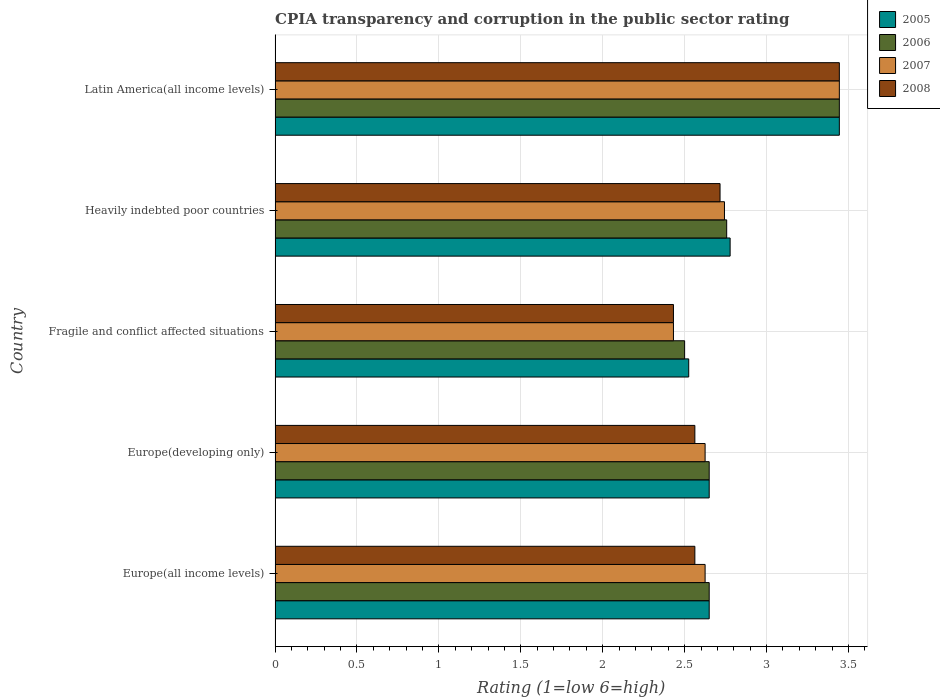How many groups of bars are there?
Provide a short and direct response. 5. Are the number of bars on each tick of the Y-axis equal?
Your answer should be compact. Yes. How many bars are there on the 1st tick from the top?
Make the answer very short. 4. What is the label of the 1st group of bars from the top?
Your answer should be compact. Latin America(all income levels). In how many cases, is the number of bars for a given country not equal to the number of legend labels?
Make the answer very short. 0. Across all countries, what is the maximum CPIA rating in 2006?
Offer a very short reply. 3.44. Across all countries, what is the minimum CPIA rating in 2005?
Provide a succinct answer. 2.52. In which country was the CPIA rating in 2005 maximum?
Keep it short and to the point. Latin America(all income levels). In which country was the CPIA rating in 2008 minimum?
Make the answer very short. Fragile and conflict affected situations. What is the total CPIA rating in 2007 in the graph?
Provide a short and direct response. 13.87. What is the difference between the CPIA rating in 2005 in Europe(developing only) and that in Heavily indebted poor countries?
Provide a succinct answer. -0.13. What is the difference between the CPIA rating in 2006 in Latin America(all income levels) and the CPIA rating in 2005 in Europe(developing only)?
Provide a short and direct response. 0.79. What is the average CPIA rating in 2005 per country?
Make the answer very short. 2.81. What is the difference between the CPIA rating in 2005 and CPIA rating in 2008 in Europe(developing only)?
Your answer should be very brief. 0.09. What is the ratio of the CPIA rating in 2008 in Fragile and conflict affected situations to that in Latin America(all income levels)?
Provide a short and direct response. 0.71. What is the difference between the highest and the second highest CPIA rating in 2006?
Your response must be concise. 0.69. What is the difference between the highest and the lowest CPIA rating in 2005?
Offer a terse response. 0.92. In how many countries, is the CPIA rating in 2006 greater than the average CPIA rating in 2006 taken over all countries?
Offer a very short reply. 1. Is the sum of the CPIA rating in 2006 in Europe(all income levels) and Latin America(all income levels) greater than the maximum CPIA rating in 2005 across all countries?
Provide a succinct answer. Yes. What does the 1st bar from the top in Fragile and conflict affected situations represents?
Give a very brief answer. 2008. What does the 4th bar from the bottom in Europe(all income levels) represents?
Offer a terse response. 2008. How many bars are there?
Keep it short and to the point. 20. What is the difference between two consecutive major ticks on the X-axis?
Offer a very short reply. 0.5. Are the values on the major ticks of X-axis written in scientific E-notation?
Ensure brevity in your answer.  No. Does the graph contain any zero values?
Your response must be concise. No. Does the graph contain grids?
Make the answer very short. Yes. Where does the legend appear in the graph?
Make the answer very short. Top right. How many legend labels are there?
Keep it short and to the point. 4. How are the legend labels stacked?
Offer a very short reply. Vertical. What is the title of the graph?
Your answer should be compact. CPIA transparency and corruption in the public sector rating. What is the Rating (1=low 6=high) in 2005 in Europe(all income levels)?
Your response must be concise. 2.65. What is the Rating (1=low 6=high) of 2006 in Europe(all income levels)?
Make the answer very short. 2.65. What is the Rating (1=low 6=high) in 2007 in Europe(all income levels)?
Provide a short and direct response. 2.62. What is the Rating (1=low 6=high) of 2008 in Europe(all income levels)?
Offer a terse response. 2.56. What is the Rating (1=low 6=high) in 2005 in Europe(developing only)?
Your response must be concise. 2.65. What is the Rating (1=low 6=high) of 2006 in Europe(developing only)?
Keep it short and to the point. 2.65. What is the Rating (1=low 6=high) of 2007 in Europe(developing only)?
Keep it short and to the point. 2.62. What is the Rating (1=low 6=high) of 2008 in Europe(developing only)?
Ensure brevity in your answer.  2.56. What is the Rating (1=low 6=high) in 2005 in Fragile and conflict affected situations?
Offer a very short reply. 2.52. What is the Rating (1=low 6=high) of 2006 in Fragile and conflict affected situations?
Ensure brevity in your answer.  2.5. What is the Rating (1=low 6=high) of 2007 in Fragile and conflict affected situations?
Ensure brevity in your answer.  2.43. What is the Rating (1=low 6=high) of 2008 in Fragile and conflict affected situations?
Your answer should be very brief. 2.43. What is the Rating (1=low 6=high) of 2005 in Heavily indebted poor countries?
Keep it short and to the point. 2.78. What is the Rating (1=low 6=high) in 2006 in Heavily indebted poor countries?
Offer a terse response. 2.76. What is the Rating (1=low 6=high) of 2007 in Heavily indebted poor countries?
Keep it short and to the point. 2.74. What is the Rating (1=low 6=high) of 2008 in Heavily indebted poor countries?
Make the answer very short. 2.72. What is the Rating (1=low 6=high) of 2005 in Latin America(all income levels)?
Give a very brief answer. 3.44. What is the Rating (1=low 6=high) in 2006 in Latin America(all income levels)?
Make the answer very short. 3.44. What is the Rating (1=low 6=high) of 2007 in Latin America(all income levels)?
Offer a very short reply. 3.44. What is the Rating (1=low 6=high) in 2008 in Latin America(all income levels)?
Ensure brevity in your answer.  3.44. Across all countries, what is the maximum Rating (1=low 6=high) of 2005?
Offer a terse response. 3.44. Across all countries, what is the maximum Rating (1=low 6=high) in 2006?
Make the answer very short. 3.44. Across all countries, what is the maximum Rating (1=low 6=high) of 2007?
Keep it short and to the point. 3.44. Across all countries, what is the maximum Rating (1=low 6=high) in 2008?
Your answer should be compact. 3.44. Across all countries, what is the minimum Rating (1=low 6=high) in 2005?
Provide a succinct answer. 2.52. Across all countries, what is the minimum Rating (1=low 6=high) of 2007?
Offer a terse response. 2.43. Across all countries, what is the minimum Rating (1=low 6=high) of 2008?
Ensure brevity in your answer.  2.43. What is the total Rating (1=low 6=high) in 2005 in the graph?
Ensure brevity in your answer.  14.05. What is the total Rating (1=low 6=high) of 2006 in the graph?
Your response must be concise. 14. What is the total Rating (1=low 6=high) in 2007 in the graph?
Ensure brevity in your answer.  13.87. What is the total Rating (1=low 6=high) of 2008 in the graph?
Provide a short and direct response. 13.72. What is the difference between the Rating (1=low 6=high) in 2005 in Europe(all income levels) and that in Europe(developing only)?
Make the answer very short. 0. What is the difference between the Rating (1=low 6=high) in 2006 in Europe(all income levels) and that in Europe(developing only)?
Offer a very short reply. 0. What is the difference between the Rating (1=low 6=high) in 2007 in Europe(all income levels) and that in Europe(developing only)?
Offer a very short reply. 0. What is the difference between the Rating (1=low 6=high) in 2008 in Europe(all income levels) and that in Europe(developing only)?
Your answer should be compact. 0. What is the difference between the Rating (1=low 6=high) in 2006 in Europe(all income levels) and that in Fragile and conflict affected situations?
Ensure brevity in your answer.  0.15. What is the difference between the Rating (1=low 6=high) in 2007 in Europe(all income levels) and that in Fragile and conflict affected situations?
Offer a very short reply. 0.19. What is the difference between the Rating (1=low 6=high) in 2008 in Europe(all income levels) and that in Fragile and conflict affected situations?
Give a very brief answer. 0.13. What is the difference between the Rating (1=low 6=high) of 2005 in Europe(all income levels) and that in Heavily indebted poor countries?
Your response must be concise. -0.13. What is the difference between the Rating (1=low 6=high) of 2006 in Europe(all income levels) and that in Heavily indebted poor countries?
Keep it short and to the point. -0.11. What is the difference between the Rating (1=low 6=high) in 2007 in Europe(all income levels) and that in Heavily indebted poor countries?
Offer a terse response. -0.12. What is the difference between the Rating (1=low 6=high) of 2008 in Europe(all income levels) and that in Heavily indebted poor countries?
Give a very brief answer. -0.15. What is the difference between the Rating (1=low 6=high) in 2005 in Europe(all income levels) and that in Latin America(all income levels)?
Give a very brief answer. -0.79. What is the difference between the Rating (1=low 6=high) in 2006 in Europe(all income levels) and that in Latin America(all income levels)?
Your answer should be very brief. -0.79. What is the difference between the Rating (1=low 6=high) in 2007 in Europe(all income levels) and that in Latin America(all income levels)?
Offer a terse response. -0.82. What is the difference between the Rating (1=low 6=high) of 2008 in Europe(all income levels) and that in Latin America(all income levels)?
Offer a very short reply. -0.88. What is the difference between the Rating (1=low 6=high) in 2005 in Europe(developing only) and that in Fragile and conflict affected situations?
Keep it short and to the point. 0.12. What is the difference between the Rating (1=low 6=high) in 2007 in Europe(developing only) and that in Fragile and conflict affected situations?
Offer a terse response. 0.19. What is the difference between the Rating (1=low 6=high) of 2008 in Europe(developing only) and that in Fragile and conflict affected situations?
Keep it short and to the point. 0.13. What is the difference between the Rating (1=low 6=high) of 2005 in Europe(developing only) and that in Heavily indebted poor countries?
Give a very brief answer. -0.13. What is the difference between the Rating (1=low 6=high) of 2006 in Europe(developing only) and that in Heavily indebted poor countries?
Your answer should be very brief. -0.11. What is the difference between the Rating (1=low 6=high) in 2007 in Europe(developing only) and that in Heavily indebted poor countries?
Ensure brevity in your answer.  -0.12. What is the difference between the Rating (1=low 6=high) of 2008 in Europe(developing only) and that in Heavily indebted poor countries?
Your answer should be compact. -0.15. What is the difference between the Rating (1=low 6=high) in 2005 in Europe(developing only) and that in Latin America(all income levels)?
Ensure brevity in your answer.  -0.79. What is the difference between the Rating (1=low 6=high) in 2006 in Europe(developing only) and that in Latin America(all income levels)?
Provide a succinct answer. -0.79. What is the difference between the Rating (1=low 6=high) of 2007 in Europe(developing only) and that in Latin America(all income levels)?
Your response must be concise. -0.82. What is the difference between the Rating (1=low 6=high) of 2008 in Europe(developing only) and that in Latin America(all income levels)?
Your response must be concise. -0.88. What is the difference between the Rating (1=low 6=high) of 2005 in Fragile and conflict affected situations and that in Heavily indebted poor countries?
Offer a very short reply. -0.25. What is the difference between the Rating (1=low 6=high) of 2006 in Fragile and conflict affected situations and that in Heavily indebted poor countries?
Ensure brevity in your answer.  -0.26. What is the difference between the Rating (1=low 6=high) in 2007 in Fragile and conflict affected situations and that in Heavily indebted poor countries?
Provide a short and direct response. -0.31. What is the difference between the Rating (1=low 6=high) in 2008 in Fragile and conflict affected situations and that in Heavily indebted poor countries?
Provide a succinct answer. -0.28. What is the difference between the Rating (1=low 6=high) in 2005 in Fragile and conflict affected situations and that in Latin America(all income levels)?
Your answer should be compact. -0.92. What is the difference between the Rating (1=low 6=high) of 2006 in Fragile and conflict affected situations and that in Latin America(all income levels)?
Your response must be concise. -0.94. What is the difference between the Rating (1=low 6=high) in 2007 in Fragile and conflict affected situations and that in Latin America(all income levels)?
Offer a terse response. -1.01. What is the difference between the Rating (1=low 6=high) in 2008 in Fragile and conflict affected situations and that in Latin America(all income levels)?
Offer a terse response. -1.01. What is the difference between the Rating (1=low 6=high) of 2006 in Heavily indebted poor countries and that in Latin America(all income levels)?
Offer a very short reply. -0.69. What is the difference between the Rating (1=low 6=high) in 2007 in Heavily indebted poor countries and that in Latin America(all income levels)?
Your answer should be compact. -0.7. What is the difference between the Rating (1=low 6=high) in 2008 in Heavily indebted poor countries and that in Latin America(all income levels)?
Your response must be concise. -0.73. What is the difference between the Rating (1=low 6=high) of 2005 in Europe(all income levels) and the Rating (1=low 6=high) of 2007 in Europe(developing only)?
Keep it short and to the point. 0.03. What is the difference between the Rating (1=low 6=high) of 2005 in Europe(all income levels) and the Rating (1=low 6=high) of 2008 in Europe(developing only)?
Your response must be concise. 0.09. What is the difference between the Rating (1=low 6=high) in 2006 in Europe(all income levels) and the Rating (1=low 6=high) in 2007 in Europe(developing only)?
Make the answer very short. 0.03. What is the difference between the Rating (1=low 6=high) in 2006 in Europe(all income levels) and the Rating (1=low 6=high) in 2008 in Europe(developing only)?
Your response must be concise. 0.09. What is the difference between the Rating (1=low 6=high) of 2007 in Europe(all income levels) and the Rating (1=low 6=high) of 2008 in Europe(developing only)?
Offer a terse response. 0.06. What is the difference between the Rating (1=low 6=high) in 2005 in Europe(all income levels) and the Rating (1=low 6=high) in 2007 in Fragile and conflict affected situations?
Keep it short and to the point. 0.22. What is the difference between the Rating (1=low 6=high) of 2005 in Europe(all income levels) and the Rating (1=low 6=high) of 2008 in Fragile and conflict affected situations?
Your answer should be very brief. 0.22. What is the difference between the Rating (1=low 6=high) of 2006 in Europe(all income levels) and the Rating (1=low 6=high) of 2007 in Fragile and conflict affected situations?
Keep it short and to the point. 0.22. What is the difference between the Rating (1=low 6=high) of 2006 in Europe(all income levels) and the Rating (1=low 6=high) of 2008 in Fragile and conflict affected situations?
Offer a terse response. 0.22. What is the difference between the Rating (1=low 6=high) in 2007 in Europe(all income levels) and the Rating (1=low 6=high) in 2008 in Fragile and conflict affected situations?
Make the answer very short. 0.19. What is the difference between the Rating (1=low 6=high) in 2005 in Europe(all income levels) and the Rating (1=low 6=high) in 2006 in Heavily indebted poor countries?
Keep it short and to the point. -0.11. What is the difference between the Rating (1=low 6=high) of 2005 in Europe(all income levels) and the Rating (1=low 6=high) of 2007 in Heavily indebted poor countries?
Your answer should be compact. -0.09. What is the difference between the Rating (1=low 6=high) of 2005 in Europe(all income levels) and the Rating (1=low 6=high) of 2008 in Heavily indebted poor countries?
Your response must be concise. -0.07. What is the difference between the Rating (1=low 6=high) of 2006 in Europe(all income levels) and the Rating (1=low 6=high) of 2007 in Heavily indebted poor countries?
Keep it short and to the point. -0.09. What is the difference between the Rating (1=low 6=high) of 2006 in Europe(all income levels) and the Rating (1=low 6=high) of 2008 in Heavily indebted poor countries?
Your response must be concise. -0.07. What is the difference between the Rating (1=low 6=high) of 2007 in Europe(all income levels) and the Rating (1=low 6=high) of 2008 in Heavily indebted poor countries?
Your answer should be very brief. -0.09. What is the difference between the Rating (1=low 6=high) in 2005 in Europe(all income levels) and the Rating (1=low 6=high) in 2006 in Latin America(all income levels)?
Keep it short and to the point. -0.79. What is the difference between the Rating (1=low 6=high) of 2005 in Europe(all income levels) and the Rating (1=low 6=high) of 2007 in Latin America(all income levels)?
Your answer should be very brief. -0.79. What is the difference between the Rating (1=low 6=high) in 2005 in Europe(all income levels) and the Rating (1=low 6=high) in 2008 in Latin America(all income levels)?
Offer a terse response. -0.79. What is the difference between the Rating (1=low 6=high) of 2006 in Europe(all income levels) and the Rating (1=low 6=high) of 2007 in Latin America(all income levels)?
Make the answer very short. -0.79. What is the difference between the Rating (1=low 6=high) of 2006 in Europe(all income levels) and the Rating (1=low 6=high) of 2008 in Latin America(all income levels)?
Your answer should be very brief. -0.79. What is the difference between the Rating (1=low 6=high) of 2007 in Europe(all income levels) and the Rating (1=low 6=high) of 2008 in Latin America(all income levels)?
Give a very brief answer. -0.82. What is the difference between the Rating (1=low 6=high) of 2005 in Europe(developing only) and the Rating (1=low 6=high) of 2007 in Fragile and conflict affected situations?
Give a very brief answer. 0.22. What is the difference between the Rating (1=low 6=high) in 2005 in Europe(developing only) and the Rating (1=low 6=high) in 2008 in Fragile and conflict affected situations?
Provide a short and direct response. 0.22. What is the difference between the Rating (1=low 6=high) in 2006 in Europe(developing only) and the Rating (1=low 6=high) in 2007 in Fragile and conflict affected situations?
Make the answer very short. 0.22. What is the difference between the Rating (1=low 6=high) in 2006 in Europe(developing only) and the Rating (1=low 6=high) in 2008 in Fragile and conflict affected situations?
Provide a short and direct response. 0.22. What is the difference between the Rating (1=low 6=high) in 2007 in Europe(developing only) and the Rating (1=low 6=high) in 2008 in Fragile and conflict affected situations?
Your answer should be compact. 0.19. What is the difference between the Rating (1=low 6=high) of 2005 in Europe(developing only) and the Rating (1=low 6=high) of 2006 in Heavily indebted poor countries?
Your answer should be very brief. -0.11. What is the difference between the Rating (1=low 6=high) of 2005 in Europe(developing only) and the Rating (1=low 6=high) of 2007 in Heavily indebted poor countries?
Your answer should be very brief. -0.09. What is the difference between the Rating (1=low 6=high) of 2005 in Europe(developing only) and the Rating (1=low 6=high) of 2008 in Heavily indebted poor countries?
Offer a terse response. -0.07. What is the difference between the Rating (1=low 6=high) of 2006 in Europe(developing only) and the Rating (1=low 6=high) of 2007 in Heavily indebted poor countries?
Offer a very short reply. -0.09. What is the difference between the Rating (1=low 6=high) in 2006 in Europe(developing only) and the Rating (1=low 6=high) in 2008 in Heavily indebted poor countries?
Ensure brevity in your answer.  -0.07. What is the difference between the Rating (1=low 6=high) of 2007 in Europe(developing only) and the Rating (1=low 6=high) of 2008 in Heavily indebted poor countries?
Keep it short and to the point. -0.09. What is the difference between the Rating (1=low 6=high) in 2005 in Europe(developing only) and the Rating (1=low 6=high) in 2006 in Latin America(all income levels)?
Offer a very short reply. -0.79. What is the difference between the Rating (1=low 6=high) of 2005 in Europe(developing only) and the Rating (1=low 6=high) of 2007 in Latin America(all income levels)?
Offer a very short reply. -0.79. What is the difference between the Rating (1=low 6=high) of 2005 in Europe(developing only) and the Rating (1=low 6=high) of 2008 in Latin America(all income levels)?
Offer a terse response. -0.79. What is the difference between the Rating (1=low 6=high) of 2006 in Europe(developing only) and the Rating (1=low 6=high) of 2007 in Latin America(all income levels)?
Offer a very short reply. -0.79. What is the difference between the Rating (1=low 6=high) of 2006 in Europe(developing only) and the Rating (1=low 6=high) of 2008 in Latin America(all income levels)?
Ensure brevity in your answer.  -0.79. What is the difference between the Rating (1=low 6=high) in 2007 in Europe(developing only) and the Rating (1=low 6=high) in 2008 in Latin America(all income levels)?
Keep it short and to the point. -0.82. What is the difference between the Rating (1=low 6=high) of 2005 in Fragile and conflict affected situations and the Rating (1=low 6=high) of 2006 in Heavily indebted poor countries?
Offer a very short reply. -0.23. What is the difference between the Rating (1=low 6=high) in 2005 in Fragile and conflict affected situations and the Rating (1=low 6=high) in 2007 in Heavily indebted poor countries?
Keep it short and to the point. -0.22. What is the difference between the Rating (1=low 6=high) of 2005 in Fragile and conflict affected situations and the Rating (1=low 6=high) of 2008 in Heavily indebted poor countries?
Provide a short and direct response. -0.19. What is the difference between the Rating (1=low 6=high) in 2006 in Fragile and conflict affected situations and the Rating (1=low 6=high) in 2007 in Heavily indebted poor countries?
Your response must be concise. -0.24. What is the difference between the Rating (1=low 6=high) of 2006 in Fragile and conflict affected situations and the Rating (1=low 6=high) of 2008 in Heavily indebted poor countries?
Your answer should be very brief. -0.22. What is the difference between the Rating (1=low 6=high) of 2007 in Fragile and conflict affected situations and the Rating (1=low 6=high) of 2008 in Heavily indebted poor countries?
Offer a very short reply. -0.28. What is the difference between the Rating (1=low 6=high) of 2005 in Fragile and conflict affected situations and the Rating (1=low 6=high) of 2006 in Latin America(all income levels)?
Offer a very short reply. -0.92. What is the difference between the Rating (1=low 6=high) of 2005 in Fragile and conflict affected situations and the Rating (1=low 6=high) of 2007 in Latin America(all income levels)?
Your answer should be very brief. -0.92. What is the difference between the Rating (1=low 6=high) in 2005 in Fragile and conflict affected situations and the Rating (1=low 6=high) in 2008 in Latin America(all income levels)?
Provide a succinct answer. -0.92. What is the difference between the Rating (1=low 6=high) in 2006 in Fragile and conflict affected situations and the Rating (1=low 6=high) in 2007 in Latin America(all income levels)?
Offer a terse response. -0.94. What is the difference between the Rating (1=low 6=high) in 2006 in Fragile and conflict affected situations and the Rating (1=low 6=high) in 2008 in Latin America(all income levels)?
Provide a succinct answer. -0.94. What is the difference between the Rating (1=low 6=high) of 2007 in Fragile and conflict affected situations and the Rating (1=low 6=high) of 2008 in Latin America(all income levels)?
Offer a terse response. -1.01. What is the difference between the Rating (1=low 6=high) in 2005 in Heavily indebted poor countries and the Rating (1=low 6=high) in 2006 in Latin America(all income levels)?
Make the answer very short. -0.67. What is the difference between the Rating (1=low 6=high) in 2005 in Heavily indebted poor countries and the Rating (1=low 6=high) in 2007 in Latin America(all income levels)?
Your answer should be very brief. -0.67. What is the difference between the Rating (1=low 6=high) of 2006 in Heavily indebted poor countries and the Rating (1=low 6=high) of 2007 in Latin America(all income levels)?
Keep it short and to the point. -0.69. What is the difference between the Rating (1=low 6=high) in 2006 in Heavily indebted poor countries and the Rating (1=low 6=high) in 2008 in Latin America(all income levels)?
Keep it short and to the point. -0.69. What is the difference between the Rating (1=low 6=high) in 2007 in Heavily indebted poor countries and the Rating (1=low 6=high) in 2008 in Latin America(all income levels)?
Make the answer very short. -0.7. What is the average Rating (1=low 6=high) in 2005 per country?
Offer a very short reply. 2.81. What is the average Rating (1=low 6=high) of 2006 per country?
Provide a short and direct response. 2.8. What is the average Rating (1=low 6=high) in 2007 per country?
Offer a terse response. 2.77. What is the average Rating (1=low 6=high) in 2008 per country?
Your answer should be compact. 2.74. What is the difference between the Rating (1=low 6=high) in 2005 and Rating (1=low 6=high) in 2007 in Europe(all income levels)?
Provide a succinct answer. 0.03. What is the difference between the Rating (1=low 6=high) of 2005 and Rating (1=low 6=high) of 2008 in Europe(all income levels)?
Your answer should be very brief. 0.09. What is the difference between the Rating (1=low 6=high) of 2006 and Rating (1=low 6=high) of 2007 in Europe(all income levels)?
Keep it short and to the point. 0.03. What is the difference between the Rating (1=low 6=high) of 2006 and Rating (1=low 6=high) of 2008 in Europe(all income levels)?
Ensure brevity in your answer.  0.09. What is the difference between the Rating (1=low 6=high) of 2007 and Rating (1=low 6=high) of 2008 in Europe(all income levels)?
Provide a succinct answer. 0.06. What is the difference between the Rating (1=low 6=high) of 2005 and Rating (1=low 6=high) of 2006 in Europe(developing only)?
Your answer should be very brief. 0. What is the difference between the Rating (1=low 6=high) of 2005 and Rating (1=low 6=high) of 2007 in Europe(developing only)?
Your answer should be compact. 0.03. What is the difference between the Rating (1=low 6=high) in 2005 and Rating (1=low 6=high) in 2008 in Europe(developing only)?
Offer a very short reply. 0.09. What is the difference between the Rating (1=low 6=high) of 2006 and Rating (1=low 6=high) of 2007 in Europe(developing only)?
Offer a very short reply. 0.03. What is the difference between the Rating (1=low 6=high) of 2006 and Rating (1=low 6=high) of 2008 in Europe(developing only)?
Offer a very short reply. 0.09. What is the difference between the Rating (1=low 6=high) in 2007 and Rating (1=low 6=high) in 2008 in Europe(developing only)?
Ensure brevity in your answer.  0.06. What is the difference between the Rating (1=low 6=high) of 2005 and Rating (1=low 6=high) of 2006 in Fragile and conflict affected situations?
Give a very brief answer. 0.03. What is the difference between the Rating (1=low 6=high) in 2005 and Rating (1=low 6=high) in 2007 in Fragile and conflict affected situations?
Offer a very short reply. 0.09. What is the difference between the Rating (1=low 6=high) of 2005 and Rating (1=low 6=high) of 2008 in Fragile and conflict affected situations?
Your answer should be compact. 0.09. What is the difference between the Rating (1=low 6=high) of 2006 and Rating (1=low 6=high) of 2007 in Fragile and conflict affected situations?
Offer a terse response. 0.07. What is the difference between the Rating (1=low 6=high) in 2006 and Rating (1=low 6=high) in 2008 in Fragile and conflict affected situations?
Your answer should be compact. 0.07. What is the difference between the Rating (1=low 6=high) in 2007 and Rating (1=low 6=high) in 2008 in Fragile and conflict affected situations?
Offer a terse response. 0. What is the difference between the Rating (1=low 6=high) of 2005 and Rating (1=low 6=high) of 2006 in Heavily indebted poor countries?
Give a very brief answer. 0.02. What is the difference between the Rating (1=low 6=high) in 2005 and Rating (1=low 6=high) in 2007 in Heavily indebted poor countries?
Offer a very short reply. 0.03. What is the difference between the Rating (1=low 6=high) of 2005 and Rating (1=low 6=high) of 2008 in Heavily indebted poor countries?
Give a very brief answer. 0.06. What is the difference between the Rating (1=low 6=high) of 2006 and Rating (1=low 6=high) of 2007 in Heavily indebted poor countries?
Provide a succinct answer. 0.01. What is the difference between the Rating (1=low 6=high) of 2006 and Rating (1=low 6=high) of 2008 in Heavily indebted poor countries?
Your response must be concise. 0.04. What is the difference between the Rating (1=low 6=high) of 2007 and Rating (1=low 6=high) of 2008 in Heavily indebted poor countries?
Give a very brief answer. 0.03. What is the difference between the Rating (1=low 6=high) in 2005 and Rating (1=low 6=high) in 2006 in Latin America(all income levels)?
Provide a succinct answer. 0. What is the difference between the Rating (1=low 6=high) of 2005 and Rating (1=low 6=high) of 2007 in Latin America(all income levels)?
Your answer should be very brief. 0. What is the difference between the Rating (1=low 6=high) of 2005 and Rating (1=low 6=high) of 2008 in Latin America(all income levels)?
Provide a short and direct response. 0. What is the difference between the Rating (1=low 6=high) in 2006 and Rating (1=low 6=high) in 2008 in Latin America(all income levels)?
Your answer should be compact. 0. What is the ratio of the Rating (1=low 6=high) of 2006 in Europe(all income levels) to that in Europe(developing only)?
Offer a very short reply. 1. What is the ratio of the Rating (1=low 6=high) of 2005 in Europe(all income levels) to that in Fragile and conflict affected situations?
Offer a very short reply. 1.05. What is the ratio of the Rating (1=low 6=high) in 2006 in Europe(all income levels) to that in Fragile and conflict affected situations?
Your response must be concise. 1.06. What is the ratio of the Rating (1=low 6=high) in 2007 in Europe(all income levels) to that in Fragile and conflict affected situations?
Provide a short and direct response. 1.08. What is the ratio of the Rating (1=low 6=high) of 2008 in Europe(all income levels) to that in Fragile and conflict affected situations?
Ensure brevity in your answer.  1.05. What is the ratio of the Rating (1=low 6=high) of 2005 in Europe(all income levels) to that in Heavily indebted poor countries?
Make the answer very short. 0.95. What is the ratio of the Rating (1=low 6=high) of 2006 in Europe(all income levels) to that in Heavily indebted poor countries?
Make the answer very short. 0.96. What is the ratio of the Rating (1=low 6=high) in 2007 in Europe(all income levels) to that in Heavily indebted poor countries?
Provide a short and direct response. 0.96. What is the ratio of the Rating (1=low 6=high) of 2008 in Europe(all income levels) to that in Heavily indebted poor countries?
Give a very brief answer. 0.94. What is the ratio of the Rating (1=low 6=high) of 2005 in Europe(all income levels) to that in Latin America(all income levels)?
Your answer should be very brief. 0.77. What is the ratio of the Rating (1=low 6=high) of 2006 in Europe(all income levels) to that in Latin America(all income levels)?
Offer a terse response. 0.77. What is the ratio of the Rating (1=low 6=high) of 2007 in Europe(all income levels) to that in Latin America(all income levels)?
Provide a short and direct response. 0.76. What is the ratio of the Rating (1=low 6=high) in 2008 in Europe(all income levels) to that in Latin America(all income levels)?
Provide a succinct answer. 0.74. What is the ratio of the Rating (1=low 6=high) of 2005 in Europe(developing only) to that in Fragile and conflict affected situations?
Provide a succinct answer. 1.05. What is the ratio of the Rating (1=low 6=high) of 2006 in Europe(developing only) to that in Fragile and conflict affected situations?
Make the answer very short. 1.06. What is the ratio of the Rating (1=low 6=high) in 2007 in Europe(developing only) to that in Fragile and conflict affected situations?
Provide a short and direct response. 1.08. What is the ratio of the Rating (1=low 6=high) of 2008 in Europe(developing only) to that in Fragile and conflict affected situations?
Provide a short and direct response. 1.05. What is the ratio of the Rating (1=low 6=high) in 2005 in Europe(developing only) to that in Heavily indebted poor countries?
Ensure brevity in your answer.  0.95. What is the ratio of the Rating (1=low 6=high) in 2006 in Europe(developing only) to that in Heavily indebted poor countries?
Make the answer very short. 0.96. What is the ratio of the Rating (1=low 6=high) of 2007 in Europe(developing only) to that in Heavily indebted poor countries?
Offer a terse response. 0.96. What is the ratio of the Rating (1=low 6=high) of 2008 in Europe(developing only) to that in Heavily indebted poor countries?
Your answer should be very brief. 0.94. What is the ratio of the Rating (1=low 6=high) in 2005 in Europe(developing only) to that in Latin America(all income levels)?
Give a very brief answer. 0.77. What is the ratio of the Rating (1=low 6=high) in 2006 in Europe(developing only) to that in Latin America(all income levels)?
Give a very brief answer. 0.77. What is the ratio of the Rating (1=low 6=high) of 2007 in Europe(developing only) to that in Latin America(all income levels)?
Your answer should be very brief. 0.76. What is the ratio of the Rating (1=low 6=high) of 2008 in Europe(developing only) to that in Latin America(all income levels)?
Your answer should be compact. 0.74. What is the ratio of the Rating (1=low 6=high) in 2005 in Fragile and conflict affected situations to that in Heavily indebted poor countries?
Make the answer very short. 0.91. What is the ratio of the Rating (1=low 6=high) of 2006 in Fragile and conflict affected situations to that in Heavily indebted poor countries?
Your answer should be very brief. 0.91. What is the ratio of the Rating (1=low 6=high) in 2007 in Fragile and conflict affected situations to that in Heavily indebted poor countries?
Your response must be concise. 0.89. What is the ratio of the Rating (1=low 6=high) of 2008 in Fragile and conflict affected situations to that in Heavily indebted poor countries?
Provide a short and direct response. 0.9. What is the ratio of the Rating (1=low 6=high) in 2005 in Fragile and conflict affected situations to that in Latin America(all income levels)?
Offer a very short reply. 0.73. What is the ratio of the Rating (1=low 6=high) in 2006 in Fragile and conflict affected situations to that in Latin America(all income levels)?
Your response must be concise. 0.73. What is the ratio of the Rating (1=low 6=high) in 2007 in Fragile and conflict affected situations to that in Latin America(all income levels)?
Offer a terse response. 0.71. What is the ratio of the Rating (1=low 6=high) of 2008 in Fragile and conflict affected situations to that in Latin America(all income levels)?
Ensure brevity in your answer.  0.71. What is the ratio of the Rating (1=low 6=high) of 2005 in Heavily indebted poor countries to that in Latin America(all income levels)?
Your answer should be compact. 0.81. What is the ratio of the Rating (1=low 6=high) in 2006 in Heavily indebted poor countries to that in Latin America(all income levels)?
Ensure brevity in your answer.  0.8. What is the ratio of the Rating (1=low 6=high) of 2007 in Heavily indebted poor countries to that in Latin America(all income levels)?
Provide a succinct answer. 0.8. What is the ratio of the Rating (1=low 6=high) in 2008 in Heavily indebted poor countries to that in Latin America(all income levels)?
Make the answer very short. 0.79. What is the difference between the highest and the second highest Rating (1=low 6=high) of 2006?
Provide a short and direct response. 0.69. What is the difference between the highest and the second highest Rating (1=low 6=high) of 2007?
Your response must be concise. 0.7. What is the difference between the highest and the second highest Rating (1=low 6=high) in 2008?
Provide a succinct answer. 0.73. What is the difference between the highest and the lowest Rating (1=low 6=high) of 2005?
Ensure brevity in your answer.  0.92. What is the difference between the highest and the lowest Rating (1=low 6=high) in 2007?
Give a very brief answer. 1.01. What is the difference between the highest and the lowest Rating (1=low 6=high) of 2008?
Ensure brevity in your answer.  1.01. 